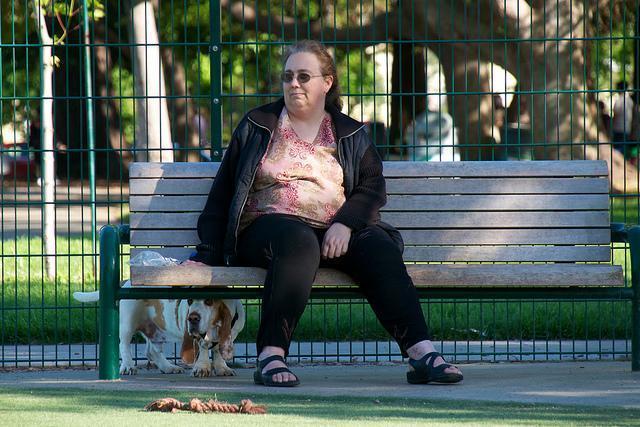What dog breed does the woman have?
Select the accurate answer and provide explanation: 'Answer: answer
Rationale: rationale.'
Options: Pug, bassett hound, dachshund, shiba inu. Answer: bassett hound.
Rationale: The breed is a hound. 